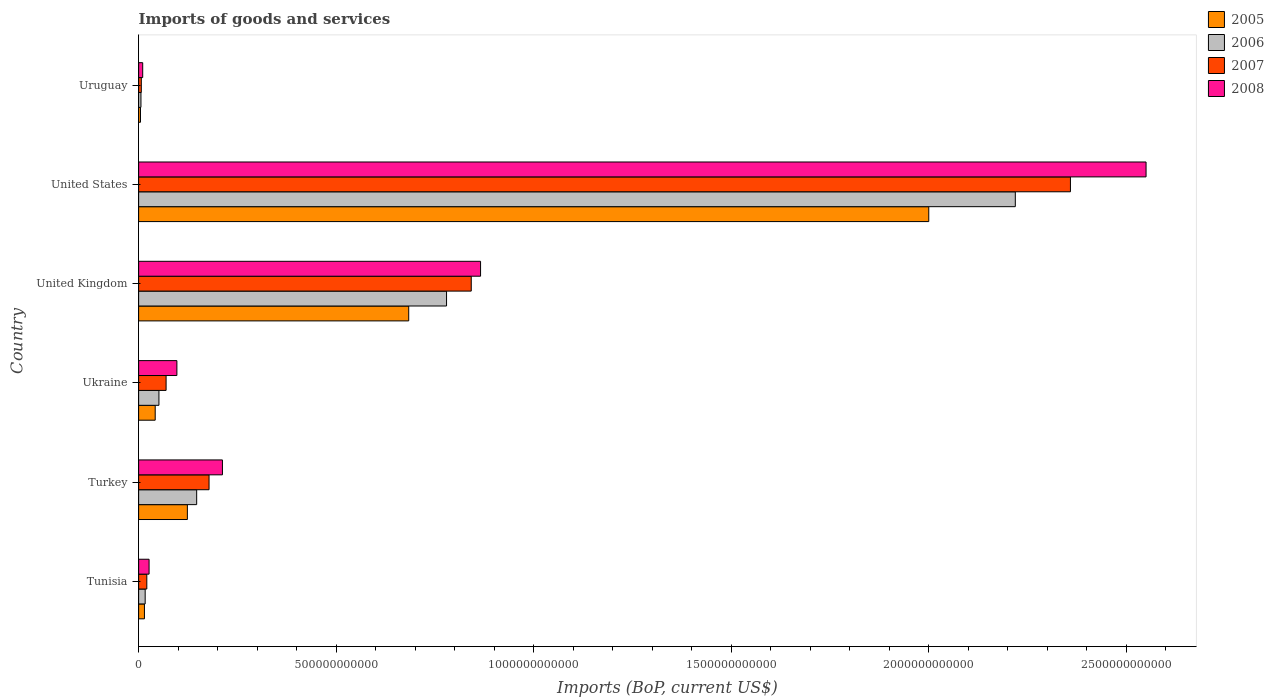Are the number of bars per tick equal to the number of legend labels?
Offer a very short reply. Yes. Are the number of bars on each tick of the Y-axis equal?
Offer a terse response. Yes. How many bars are there on the 5th tick from the top?
Provide a short and direct response. 4. What is the label of the 5th group of bars from the top?
Offer a terse response. Turkey. In how many cases, is the number of bars for a given country not equal to the number of legend labels?
Make the answer very short. 0. What is the amount spent on imports in 2007 in Uruguay?
Your answer should be very brief. 6.78e+09. Across all countries, what is the maximum amount spent on imports in 2006?
Make the answer very short. 2.22e+12. Across all countries, what is the minimum amount spent on imports in 2008?
Your answer should be compact. 1.03e+1. In which country was the amount spent on imports in 2006 maximum?
Make the answer very short. United States. In which country was the amount spent on imports in 2005 minimum?
Your answer should be very brief. Uruguay. What is the total amount spent on imports in 2005 in the graph?
Offer a terse response. 2.87e+12. What is the difference between the amount spent on imports in 2006 in United States and that in Uruguay?
Your answer should be very brief. 2.21e+12. What is the difference between the amount spent on imports in 2007 in Tunisia and the amount spent on imports in 2008 in Turkey?
Ensure brevity in your answer.  -1.91e+11. What is the average amount spent on imports in 2007 per country?
Provide a short and direct response. 5.79e+11. What is the difference between the amount spent on imports in 2006 and amount spent on imports in 2005 in Tunisia?
Keep it short and to the point. 1.86e+09. What is the ratio of the amount spent on imports in 2008 in Tunisia to that in Uruguay?
Provide a short and direct response. 2.56. Is the amount spent on imports in 2006 in Ukraine less than that in United Kingdom?
Give a very brief answer. Yes. What is the difference between the highest and the second highest amount spent on imports in 2006?
Offer a very short reply. 1.44e+12. What is the difference between the highest and the lowest amount spent on imports in 2006?
Your answer should be compact. 2.21e+12. In how many countries, is the amount spent on imports in 2008 greater than the average amount spent on imports in 2008 taken over all countries?
Offer a terse response. 2. Is the sum of the amount spent on imports in 2008 in Tunisia and Uruguay greater than the maximum amount spent on imports in 2006 across all countries?
Offer a very short reply. No. What does the 4th bar from the bottom in United Kingdom represents?
Ensure brevity in your answer.  2008. How many bars are there?
Keep it short and to the point. 24. Are all the bars in the graph horizontal?
Your answer should be compact. Yes. How many countries are there in the graph?
Provide a succinct answer. 6. What is the difference between two consecutive major ticks on the X-axis?
Provide a short and direct response. 5.00e+11. Does the graph contain any zero values?
Your answer should be very brief. No. Does the graph contain grids?
Keep it short and to the point. No. How many legend labels are there?
Offer a very short reply. 4. What is the title of the graph?
Your answer should be compact. Imports of goods and services. Does "1991" appear as one of the legend labels in the graph?
Ensure brevity in your answer.  No. What is the label or title of the X-axis?
Provide a succinct answer. Imports (BoP, current US$). What is the Imports (BoP, current US$) of 2005 in Tunisia?
Make the answer very short. 1.47e+1. What is the Imports (BoP, current US$) of 2006 in Tunisia?
Keep it short and to the point. 1.66e+1. What is the Imports (BoP, current US$) in 2007 in Tunisia?
Ensure brevity in your answer.  2.07e+1. What is the Imports (BoP, current US$) in 2008 in Tunisia?
Your answer should be very brief. 2.64e+1. What is the Imports (BoP, current US$) in 2005 in Turkey?
Offer a terse response. 1.23e+11. What is the Imports (BoP, current US$) in 2006 in Turkey?
Make the answer very short. 1.47e+11. What is the Imports (BoP, current US$) of 2007 in Turkey?
Your response must be concise. 1.78e+11. What is the Imports (BoP, current US$) in 2008 in Turkey?
Make the answer very short. 2.12e+11. What is the Imports (BoP, current US$) in 2005 in Ukraine?
Provide a succinct answer. 4.20e+1. What is the Imports (BoP, current US$) in 2006 in Ukraine?
Your response must be concise. 5.14e+1. What is the Imports (BoP, current US$) of 2007 in Ukraine?
Ensure brevity in your answer.  6.95e+1. What is the Imports (BoP, current US$) in 2008 in Ukraine?
Offer a very short reply. 9.68e+1. What is the Imports (BoP, current US$) in 2005 in United Kingdom?
Offer a terse response. 6.84e+11. What is the Imports (BoP, current US$) of 2006 in United Kingdom?
Provide a succinct answer. 7.80e+11. What is the Imports (BoP, current US$) in 2007 in United Kingdom?
Offer a terse response. 8.42e+11. What is the Imports (BoP, current US$) in 2008 in United Kingdom?
Make the answer very short. 8.66e+11. What is the Imports (BoP, current US$) in 2005 in United States?
Provide a succinct answer. 2.00e+12. What is the Imports (BoP, current US$) in 2006 in United States?
Make the answer very short. 2.22e+12. What is the Imports (BoP, current US$) of 2007 in United States?
Give a very brief answer. 2.36e+12. What is the Imports (BoP, current US$) in 2008 in United States?
Your response must be concise. 2.55e+12. What is the Imports (BoP, current US$) of 2005 in Uruguay?
Give a very brief answer. 4.69e+09. What is the Imports (BoP, current US$) of 2006 in Uruguay?
Your response must be concise. 5.88e+09. What is the Imports (BoP, current US$) in 2007 in Uruguay?
Your response must be concise. 6.78e+09. What is the Imports (BoP, current US$) of 2008 in Uruguay?
Make the answer very short. 1.03e+1. Across all countries, what is the maximum Imports (BoP, current US$) of 2005?
Ensure brevity in your answer.  2.00e+12. Across all countries, what is the maximum Imports (BoP, current US$) in 2006?
Your answer should be compact. 2.22e+12. Across all countries, what is the maximum Imports (BoP, current US$) in 2007?
Make the answer very short. 2.36e+12. Across all countries, what is the maximum Imports (BoP, current US$) in 2008?
Keep it short and to the point. 2.55e+12. Across all countries, what is the minimum Imports (BoP, current US$) of 2005?
Offer a terse response. 4.69e+09. Across all countries, what is the minimum Imports (BoP, current US$) in 2006?
Ensure brevity in your answer.  5.88e+09. Across all countries, what is the minimum Imports (BoP, current US$) in 2007?
Your response must be concise. 6.78e+09. Across all countries, what is the minimum Imports (BoP, current US$) of 2008?
Ensure brevity in your answer.  1.03e+1. What is the total Imports (BoP, current US$) in 2005 in the graph?
Keep it short and to the point. 2.87e+12. What is the total Imports (BoP, current US$) of 2006 in the graph?
Provide a succinct answer. 3.22e+12. What is the total Imports (BoP, current US$) in 2007 in the graph?
Your answer should be compact. 3.48e+12. What is the total Imports (BoP, current US$) of 2008 in the graph?
Give a very brief answer. 3.76e+12. What is the difference between the Imports (BoP, current US$) of 2005 in Tunisia and that in Turkey?
Ensure brevity in your answer.  -1.09e+11. What is the difference between the Imports (BoP, current US$) of 2006 in Tunisia and that in Turkey?
Your answer should be very brief. -1.30e+11. What is the difference between the Imports (BoP, current US$) of 2007 in Tunisia and that in Turkey?
Your answer should be very brief. -1.58e+11. What is the difference between the Imports (BoP, current US$) of 2008 in Tunisia and that in Turkey?
Make the answer very short. -1.86e+11. What is the difference between the Imports (BoP, current US$) in 2005 in Tunisia and that in Ukraine?
Provide a succinct answer. -2.73e+1. What is the difference between the Imports (BoP, current US$) in 2006 in Tunisia and that in Ukraine?
Your answer should be very brief. -3.49e+1. What is the difference between the Imports (BoP, current US$) of 2007 in Tunisia and that in Ukraine?
Keep it short and to the point. -4.88e+1. What is the difference between the Imports (BoP, current US$) of 2008 in Tunisia and that in Ukraine?
Your answer should be very brief. -7.04e+1. What is the difference between the Imports (BoP, current US$) in 2005 in Tunisia and that in United Kingdom?
Give a very brief answer. -6.69e+11. What is the difference between the Imports (BoP, current US$) in 2006 in Tunisia and that in United Kingdom?
Your answer should be very brief. -7.63e+11. What is the difference between the Imports (BoP, current US$) in 2007 in Tunisia and that in United Kingdom?
Offer a very short reply. -8.21e+11. What is the difference between the Imports (BoP, current US$) of 2008 in Tunisia and that in United Kingdom?
Your response must be concise. -8.39e+11. What is the difference between the Imports (BoP, current US$) of 2005 in Tunisia and that in United States?
Keep it short and to the point. -1.99e+12. What is the difference between the Imports (BoP, current US$) in 2006 in Tunisia and that in United States?
Make the answer very short. -2.20e+12. What is the difference between the Imports (BoP, current US$) of 2007 in Tunisia and that in United States?
Keep it short and to the point. -2.34e+12. What is the difference between the Imports (BoP, current US$) of 2008 in Tunisia and that in United States?
Give a very brief answer. -2.52e+12. What is the difference between the Imports (BoP, current US$) in 2005 in Tunisia and that in Uruguay?
Your answer should be very brief. 1.00e+1. What is the difference between the Imports (BoP, current US$) of 2006 in Tunisia and that in Uruguay?
Keep it short and to the point. 1.07e+1. What is the difference between the Imports (BoP, current US$) of 2007 in Tunisia and that in Uruguay?
Give a very brief answer. 1.40e+1. What is the difference between the Imports (BoP, current US$) in 2008 in Tunisia and that in Uruguay?
Keep it short and to the point. 1.61e+1. What is the difference between the Imports (BoP, current US$) of 2005 in Turkey and that in Ukraine?
Make the answer very short. 8.14e+1. What is the difference between the Imports (BoP, current US$) in 2006 in Turkey and that in Ukraine?
Provide a short and direct response. 9.55e+1. What is the difference between the Imports (BoP, current US$) of 2007 in Turkey and that in Ukraine?
Your answer should be compact. 1.09e+11. What is the difference between the Imports (BoP, current US$) of 2008 in Turkey and that in Ukraine?
Your response must be concise. 1.15e+11. What is the difference between the Imports (BoP, current US$) in 2005 in Turkey and that in United Kingdom?
Provide a succinct answer. -5.60e+11. What is the difference between the Imports (BoP, current US$) in 2006 in Turkey and that in United Kingdom?
Provide a short and direct response. -6.33e+11. What is the difference between the Imports (BoP, current US$) of 2007 in Turkey and that in United Kingdom?
Ensure brevity in your answer.  -6.64e+11. What is the difference between the Imports (BoP, current US$) in 2008 in Turkey and that in United Kingdom?
Provide a succinct answer. -6.53e+11. What is the difference between the Imports (BoP, current US$) in 2005 in Turkey and that in United States?
Your response must be concise. -1.88e+12. What is the difference between the Imports (BoP, current US$) of 2006 in Turkey and that in United States?
Provide a short and direct response. -2.07e+12. What is the difference between the Imports (BoP, current US$) of 2007 in Turkey and that in United States?
Offer a terse response. -2.18e+12. What is the difference between the Imports (BoP, current US$) in 2008 in Turkey and that in United States?
Make the answer very short. -2.34e+12. What is the difference between the Imports (BoP, current US$) in 2005 in Turkey and that in Uruguay?
Keep it short and to the point. 1.19e+11. What is the difference between the Imports (BoP, current US$) in 2006 in Turkey and that in Uruguay?
Provide a succinct answer. 1.41e+11. What is the difference between the Imports (BoP, current US$) of 2007 in Turkey and that in Uruguay?
Your answer should be compact. 1.72e+11. What is the difference between the Imports (BoP, current US$) in 2008 in Turkey and that in Uruguay?
Keep it short and to the point. 2.02e+11. What is the difference between the Imports (BoP, current US$) in 2005 in Ukraine and that in United Kingdom?
Make the answer very short. -6.42e+11. What is the difference between the Imports (BoP, current US$) in 2006 in Ukraine and that in United Kingdom?
Offer a terse response. -7.28e+11. What is the difference between the Imports (BoP, current US$) of 2007 in Ukraine and that in United Kingdom?
Ensure brevity in your answer.  -7.72e+11. What is the difference between the Imports (BoP, current US$) in 2008 in Ukraine and that in United Kingdom?
Offer a terse response. -7.69e+11. What is the difference between the Imports (BoP, current US$) of 2005 in Ukraine and that in United States?
Your answer should be compact. -1.96e+12. What is the difference between the Imports (BoP, current US$) in 2006 in Ukraine and that in United States?
Your answer should be very brief. -2.17e+12. What is the difference between the Imports (BoP, current US$) in 2007 in Ukraine and that in United States?
Make the answer very short. -2.29e+12. What is the difference between the Imports (BoP, current US$) in 2008 in Ukraine and that in United States?
Ensure brevity in your answer.  -2.45e+12. What is the difference between the Imports (BoP, current US$) of 2005 in Ukraine and that in Uruguay?
Your response must be concise. 3.73e+1. What is the difference between the Imports (BoP, current US$) of 2006 in Ukraine and that in Uruguay?
Ensure brevity in your answer.  4.55e+1. What is the difference between the Imports (BoP, current US$) of 2007 in Ukraine and that in Uruguay?
Your answer should be very brief. 6.28e+1. What is the difference between the Imports (BoP, current US$) of 2008 in Ukraine and that in Uruguay?
Ensure brevity in your answer.  8.65e+1. What is the difference between the Imports (BoP, current US$) in 2005 in United Kingdom and that in United States?
Keep it short and to the point. -1.32e+12. What is the difference between the Imports (BoP, current US$) of 2006 in United Kingdom and that in United States?
Ensure brevity in your answer.  -1.44e+12. What is the difference between the Imports (BoP, current US$) in 2007 in United Kingdom and that in United States?
Your answer should be compact. -1.52e+12. What is the difference between the Imports (BoP, current US$) in 2008 in United Kingdom and that in United States?
Give a very brief answer. -1.68e+12. What is the difference between the Imports (BoP, current US$) of 2005 in United Kingdom and that in Uruguay?
Your answer should be very brief. 6.79e+11. What is the difference between the Imports (BoP, current US$) of 2006 in United Kingdom and that in Uruguay?
Make the answer very short. 7.74e+11. What is the difference between the Imports (BoP, current US$) in 2007 in United Kingdom and that in Uruguay?
Ensure brevity in your answer.  8.35e+11. What is the difference between the Imports (BoP, current US$) of 2008 in United Kingdom and that in Uruguay?
Make the answer very short. 8.55e+11. What is the difference between the Imports (BoP, current US$) in 2005 in United States and that in Uruguay?
Offer a very short reply. 2.00e+12. What is the difference between the Imports (BoP, current US$) in 2006 in United States and that in Uruguay?
Provide a short and direct response. 2.21e+12. What is the difference between the Imports (BoP, current US$) in 2007 in United States and that in Uruguay?
Provide a short and direct response. 2.35e+12. What is the difference between the Imports (BoP, current US$) of 2008 in United States and that in Uruguay?
Your answer should be very brief. 2.54e+12. What is the difference between the Imports (BoP, current US$) in 2005 in Tunisia and the Imports (BoP, current US$) in 2006 in Turkey?
Make the answer very short. -1.32e+11. What is the difference between the Imports (BoP, current US$) in 2005 in Tunisia and the Imports (BoP, current US$) in 2007 in Turkey?
Keep it short and to the point. -1.64e+11. What is the difference between the Imports (BoP, current US$) of 2005 in Tunisia and the Imports (BoP, current US$) of 2008 in Turkey?
Make the answer very short. -1.97e+11. What is the difference between the Imports (BoP, current US$) of 2006 in Tunisia and the Imports (BoP, current US$) of 2007 in Turkey?
Give a very brief answer. -1.62e+11. What is the difference between the Imports (BoP, current US$) in 2006 in Tunisia and the Imports (BoP, current US$) in 2008 in Turkey?
Provide a succinct answer. -1.96e+11. What is the difference between the Imports (BoP, current US$) of 2007 in Tunisia and the Imports (BoP, current US$) of 2008 in Turkey?
Give a very brief answer. -1.91e+11. What is the difference between the Imports (BoP, current US$) of 2005 in Tunisia and the Imports (BoP, current US$) of 2006 in Ukraine?
Your response must be concise. -3.67e+1. What is the difference between the Imports (BoP, current US$) in 2005 in Tunisia and the Imports (BoP, current US$) in 2007 in Ukraine?
Give a very brief answer. -5.48e+1. What is the difference between the Imports (BoP, current US$) in 2005 in Tunisia and the Imports (BoP, current US$) in 2008 in Ukraine?
Keep it short and to the point. -8.21e+1. What is the difference between the Imports (BoP, current US$) of 2006 in Tunisia and the Imports (BoP, current US$) of 2007 in Ukraine?
Make the answer very short. -5.30e+1. What is the difference between the Imports (BoP, current US$) of 2006 in Tunisia and the Imports (BoP, current US$) of 2008 in Ukraine?
Your answer should be very brief. -8.03e+1. What is the difference between the Imports (BoP, current US$) in 2007 in Tunisia and the Imports (BoP, current US$) in 2008 in Ukraine?
Ensure brevity in your answer.  -7.61e+1. What is the difference between the Imports (BoP, current US$) of 2005 in Tunisia and the Imports (BoP, current US$) of 2006 in United Kingdom?
Give a very brief answer. -7.65e+11. What is the difference between the Imports (BoP, current US$) of 2005 in Tunisia and the Imports (BoP, current US$) of 2007 in United Kingdom?
Your answer should be compact. -8.27e+11. What is the difference between the Imports (BoP, current US$) in 2005 in Tunisia and the Imports (BoP, current US$) in 2008 in United Kingdom?
Make the answer very short. -8.51e+11. What is the difference between the Imports (BoP, current US$) in 2006 in Tunisia and the Imports (BoP, current US$) in 2007 in United Kingdom?
Give a very brief answer. -8.25e+11. What is the difference between the Imports (BoP, current US$) in 2006 in Tunisia and the Imports (BoP, current US$) in 2008 in United Kingdom?
Offer a very short reply. -8.49e+11. What is the difference between the Imports (BoP, current US$) of 2007 in Tunisia and the Imports (BoP, current US$) of 2008 in United Kingdom?
Provide a short and direct response. -8.45e+11. What is the difference between the Imports (BoP, current US$) in 2005 in Tunisia and the Imports (BoP, current US$) in 2006 in United States?
Offer a terse response. -2.20e+12. What is the difference between the Imports (BoP, current US$) in 2005 in Tunisia and the Imports (BoP, current US$) in 2007 in United States?
Your answer should be compact. -2.34e+12. What is the difference between the Imports (BoP, current US$) in 2005 in Tunisia and the Imports (BoP, current US$) in 2008 in United States?
Provide a succinct answer. -2.54e+12. What is the difference between the Imports (BoP, current US$) of 2006 in Tunisia and the Imports (BoP, current US$) of 2007 in United States?
Offer a terse response. -2.34e+12. What is the difference between the Imports (BoP, current US$) of 2006 in Tunisia and the Imports (BoP, current US$) of 2008 in United States?
Offer a terse response. -2.53e+12. What is the difference between the Imports (BoP, current US$) of 2007 in Tunisia and the Imports (BoP, current US$) of 2008 in United States?
Your response must be concise. -2.53e+12. What is the difference between the Imports (BoP, current US$) in 2005 in Tunisia and the Imports (BoP, current US$) in 2006 in Uruguay?
Provide a short and direct response. 8.82e+09. What is the difference between the Imports (BoP, current US$) of 2005 in Tunisia and the Imports (BoP, current US$) of 2007 in Uruguay?
Ensure brevity in your answer.  7.93e+09. What is the difference between the Imports (BoP, current US$) of 2005 in Tunisia and the Imports (BoP, current US$) of 2008 in Uruguay?
Keep it short and to the point. 4.37e+09. What is the difference between the Imports (BoP, current US$) of 2006 in Tunisia and the Imports (BoP, current US$) of 2007 in Uruguay?
Your response must be concise. 9.79e+09. What is the difference between the Imports (BoP, current US$) in 2006 in Tunisia and the Imports (BoP, current US$) in 2008 in Uruguay?
Offer a very short reply. 6.23e+09. What is the difference between the Imports (BoP, current US$) of 2007 in Tunisia and the Imports (BoP, current US$) of 2008 in Uruguay?
Keep it short and to the point. 1.04e+1. What is the difference between the Imports (BoP, current US$) of 2005 in Turkey and the Imports (BoP, current US$) of 2006 in Ukraine?
Give a very brief answer. 7.20e+1. What is the difference between the Imports (BoP, current US$) of 2005 in Turkey and the Imports (BoP, current US$) of 2007 in Ukraine?
Give a very brief answer. 5.39e+1. What is the difference between the Imports (BoP, current US$) of 2005 in Turkey and the Imports (BoP, current US$) of 2008 in Ukraine?
Your answer should be compact. 2.65e+1. What is the difference between the Imports (BoP, current US$) of 2006 in Turkey and the Imports (BoP, current US$) of 2007 in Ukraine?
Your answer should be very brief. 7.74e+1. What is the difference between the Imports (BoP, current US$) of 2006 in Turkey and the Imports (BoP, current US$) of 2008 in Ukraine?
Give a very brief answer. 5.01e+1. What is the difference between the Imports (BoP, current US$) of 2007 in Turkey and the Imports (BoP, current US$) of 2008 in Ukraine?
Provide a short and direct response. 8.14e+1. What is the difference between the Imports (BoP, current US$) in 2005 in Turkey and the Imports (BoP, current US$) in 2006 in United Kingdom?
Your response must be concise. -6.56e+11. What is the difference between the Imports (BoP, current US$) of 2005 in Turkey and the Imports (BoP, current US$) of 2007 in United Kingdom?
Your answer should be very brief. -7.19e+11. What is the difference between the Imports (BoP, current US$) of 2005 in Turkey and the Imports (BoP, current US$) of 2008 in United Kingdom?
Your response must be concise. -7.42e+11. What is the difference between the Imports (BoP, current US$) of 2006 in Turkey and the Imports (BoP, current US$) of 2007 in United Kingdom?
Your answer should be compact. -6.95e+11. What is the difference between the Imports (BoP, current US$) in 2006 in Turkey and the Imports (BoP, current US$) in 2008 in United Kingdom?
Offer a terse response. -7.19e+11. What is the difference between the Imports (BoP, current US$) of 2007 in Turkey and the Imports (BoP, current US$) of 2008 in United Kingdom?
Ensure brevity in your answer.  -6.87e+11. What is the difference between the Imports (BoP, current US$) of 2005 in Turkey and the Imports (BoP, current US$) of 2006 in United States?
Give a very brief answer. -2.10e+12. What is the difference between the Imports (BoP, current US$) of 2005 in Turkey and the Imports (BoP, current US$) of 2007 in United States?
Give a very brief answer. -2.24e+12. What is the difference between the Imports (BoP, current US$) in 2005 in Turkey and the Imports (BoP, current US$) in 2008 in United States?
Offer a terse response. -2.43e+12. What is the difference between the Imports (BoP, current US$) in 2006 in Turkey and the Imports (BoP, current US$) in 2007 in United States?
Offer a terse response. -2.21e+12. What is the difference between the Imports (BoP, current US$) of 2006 in Turkey and the Imports (BoP, current US$) of 2008 in United States?
Provide a short and direct response. -2.40e+12. What is the difference between the Imports (BoP, current US$) in 2007 in Turkey and the Imports (BoP, current US$) in 2008 in United States?
Give a very brief answer. -2.37e+12. What is the difference between the Imports (BoP, current US$) in 2005 in Turkey and the Imports (BoP, current US$) in 2006 in Uruguay?
Provide a succinct answer. 1.18e+11. What is the difference between the Imports (BoP, current US$) of 2005 in Turkey and the Imports (BoP, current US$) of 2007 in Uruguay?
Make the answer very short. 1.17e+11. What is the difference between the Imports (BoP, current US$) in 2005 in Turkey and the Imports (BoP, current US$) in 2008 in Uruguay?
Give a very brief answer. 1.13e+11. What is the difference between the Imports (BoP, current US$) in 2006 in Turkey and the Imports (BoP, current US$) in 2007 in Uruguay?
Your answer should be very brief. 1.40e+11. What is the difference between the Imports (BoP, current US$) of 2006 in Turkey and the Imports (BoP, current US$) of 2008 in Uruguay?
Make the answer very short. 1.37e+11. What is the difference between the Imports (BoP, current US$) in 2007 in Turkey and the Imports (BoP, current US$) in 2008 in Uruguay?
Offer a very short reply. 1.68e+11. What is the difference between the Imports (BoP, current US$) in 2005 in Ukraine and the Imports (BoP, current US$) in 2006 in United Kingdom?
Offer a very short reply. -7.38e+11. What is the difference between the Imports (BoP, current US$) in 2005 in Ukraine and the Imports (BoP, current US$) in 2007 in United Kingdom?
Ensure brevity in your answer.  -8.00e+11. What is the difference between the Imports (BoP, current US$) of 2005 in Ukraine and the Imports (BoP, current US$) of 2008 in United Kingdom?
Your answer should be compact. -8.24e+11. What is the difference between the Imports (BoP, current US$) in 2006 in Ukraine and the Imports (BoP, current US$) in 2007 in United Kingdom?
Your answer should be very brief. -7.91e+11. What is the difference between the Imports (BoP, current US$) in 2006 in Ukraine and the Imports (BoP, current US$) in 2008 in United Kingdom?
Ensure brevity in your answer.  -8.14e+11. What is the difference between the Imports (BoP, current US$) in 2007 in Ukraine and the Imports (BoP, current US$) in 2008 in United Kingdom?
Ensure brevity in your answer.  -7.96e+11. What is the difference between the Imports (BoP, current US$) in 2005 in Ukraine and the Imports (BoP, current US$) in 2006 in United States?
Offer a terse response. -2.18e+12. What is the difference between the Imports (BoP, current US$) in 2005 in Ukraine and the Imports (BoP, current US$) in 2007 in United States?
Offer a terse response. -2.32e+12. What is the difference between the Imports (BoP, current US$) in 2005 in Ukraine and the Imports (BoP, current US$) in 2008 in United States?
Provide a succinct answer. -2.51e+12. What is the difference between the Imports (BoP, current US$) of 2006 in Ukraine and the Imports (BoP, current US$) of 2007 in United States?
Make the answer very short. -2.31e+12. What is the difference between the Imports (BoP, current US$) in 2006 in Ukraine and the Imports (BoP, current US$) in 2008 in United States?
Your answer should be very brief. -2.50e+12. What is the difference between the Imports (BoP, current US$) of 2007 in Ukraine and the Imports (BoP, current US$) of 2008 in United States?
Your answer should be very brief. -2.48e+12. What is the difference between the Imports (BoP, current US$) of 2005 in Ukraine and the Imports (BoP, current US$) of 2006 in Uruguay?
Make the answer very short. 3.61e+1. What is the difference between the Imports (BoP, current US$) of 2005 in Ukraine and the Imports (BoP, current US$) of 2007 in Uruguay?
Your answer should be compact. 3.52e+1. What is the difference between the Imports (BoP, current US$) of 2005 in Ukraine and the Imports (BoP, current US$) of 2008 in Uruguay?
Ensure brevity in your answer.  3.16e+1. What is the difference between the Imports (BoP, current US$) of 2006 in Ukraine and the Imports (BoP, current US$) of 2007 in Uruguay?
Make the answer very short. 4.46e+1. What is the difference between the Imports (BoP, current US$) in 2006 in Ukraine and the Imports (BoP, current US$) in 2008 in Uruguay?
Ensure brevity in your answer.  4.11e+1. What is the difference between the Imports (BoP, current US$) in 2007 in Ukraine and the Imports (BoP, current US$) in 2008 in Uruguay?
Keep it short and to the point. 5.92e+1. What is the difference between the Imports (BoP, current US$) in 2005 in United Kingdom and the Imports (BoP, current US$) in 2006 in United States?
Your answer should be very brief. -1.54e+12. What is the difference between the Imports (BoP, current US$) of 2005 in United Kingdom and the Imports (BoP, current US$) of 2007 in United States?
Ensure brevity in your answer.  -1.68e+12. What is the difference between the Imports (BoP, current US$) in 2005 in United Kingdom and the Imports (BoP, current US$) in 2008 in United States?
Make the answer very short. -1.87e+12. What is the difference between the Imports (BoP, current US$) of 2006 in United Kingdom and the Imports (BoP, current US$) of 2007 in United States?
Offer a very short reply. -1.58e+12. What is the difference between the Imports (BoP, current US$) of 2006 in United Kingdom and the Imports (BoP, current US$) of 2008 in United States?
Your response must be concise. -1.77e+12. What is the difference between the Imports (BoP, current US$) of 2007 in United Kingdom and the Imports (BoP, current US$) of 2008 in United States?
Your response must be concise. -1.71e+12. What is the difference between the Imports (BoP, current US$) in 2005 in United Kingdom and the Imports (BoP, current US$) in 2006 in Uruguay?
Offer a very short reply. 6.78e+11. What is the difference between the Imports (BoP, current US$) in 2005 in United Kingdom and the Imports (BoP, current US$) in 2007 in Uruguay?
Provide a succinct answer. 6.77e+11. What is the difference between the Imports (BoP, current US$) of 2005 in United Kingdom and the Imports (BoP, current US$) of 2008 in Uruguay?
Offer a very short reply. 6.73e+11. What is the difference between the Imports (BoP, current US$) of 2006 in United Kingdom and the Imports (BoP, current US$) of 2007 in Uruguay?
Your answer should be compact. 7.73e+11. What is the difference between the Imports (BoP, current US$) of 2006 in United Kingdom and the Imports (BoP, current US$) of 2008 in Uruguay?
Your response must be concise. 7.69e+11. What is the difference between the Imports (BoP, current US$) in 2007 in United Kingdom and the Imports (BoP, current US$) in 2008 in Uruguay?
Ensure brevity in your answer.  8.32e+11. What is the difference between the Imports (BoP, current US$) of 2005 in United States and the Imports (BoP, current US$) of 2006 in Uruguay?
Offer a terse response. 1.99e+12. What is the difference between the Imports (BoP, current US$) of 2005 in United States and the Imports (BoP, current US$) of 2007 in Uruguay?
Give a very brief answer. 1.99e+12. What is the difference between the Imports (BoP, current US$) in 2005 in United States and the Imports (BoP, current US$) in 2008 in Uruguay?
Provide a short and direct response. 1.99e+12. What is the difference between the Imports (BoP, current US$) in 2006 in United States and the Imports (BoP, current US$) in 2007 in Uruguay?
Provide a succinct answer. 2.21e+12. What is the difference between the Imports (BoP, current US$) in 2006 in United States and the Imports (BoP, current US$) in 2008 in Uruguay?
Offer a very short reply. 2.21e+12. What is the difference between the Imports (BoP, current US$) in 2007 in United States and the Imports (BoP, current US$) in 2008 in Uruguay?
Give a very brief answer. 2.35e+12. What is the average Imports (BoP, current US$) of 2005 per country?
Your answer should be very brief. 4.78e+11. What is the average Imports (BoP, current US$) of 2006 per country?
Give a very brief answer. 5.37e+11. What is the average Imports (BoP, current US$) of 2007 per country?
Your answer should be very brief. 5.79e+11. What is the average Imports (BoP, current US$) of 2008 per country?
Your answer should be compact. 6.27e+11. What is the difference between the Imports (BoP, current US$) of 2005 and Imports (BoP, current US$) of 2006 in Tunisia?
Make the answer very short. -1.86e+09. What is the difference between the Imports (BoP, current US$) in 2005 and Imports (BoP, current US$) in 2007 in Tunisia?
Ensure brevity in your answer.  -6.03e+09. What is the difference between the Imports (BoP, current US$) in 2005 and Imports (BoP, current US$) in 2008 in Tunisia?
Offer a terse response. -1.17e+1. What is the difference between the Imports (BoP, current US$) in 2006 and Imports (BoP, current US$) in 2007 in Tunisia?
Give a very brief answer. -4.17e+09. What is the difference between the Imports (BoP, current US$) in 2006 and Imports (BoP, current US$) in 2008 in Tunisia?
Your answer should be compact. -9.88e+09. What is the difference between the Imports (BoP, current US$) of 2007 and Imports (BoP, current US$) of 2008 in Tunisia?
Offer a very short reply. -5.71e+09. What is the difference between the Imports (BoP, current US$) in 2005 and Imports (BoP, current US$) in 2006 in Turkey?
Your answer should be very brief. -2.35e+1. What is the difference between the Imports (BoP, current US$) in 2005 and Imports (BoP, current US$) in 2007 in Turkey?
Your answer should be very brief. -5.49e+1. What is the difference between the Imports (BoP, current US$) in 2005 and Imports (BoP, current US$) in 2008 in Turkey?
Your answer should be very brief. -8.88e+1. What is the difference between the Imports (BoP, current US$) of 2006 and Imports (BoP, current US$) of 2007 in Turkey?
Your answer should be very brief. -3.13e+1. What is the difference between the Imports (BoP, current US$) of 2006 and Imports (BoP, current US$) of 2008 in Turkey?
Your answer should be very brief. -6.52e+1. What is the difference between the Imports (BoP, current US$) of 2007 and Imports (BoP, current US$) of 2008 in Turkey?
Your answer should be compact. -3.39e+1. What is the difference between the Imports (BoP, current US$) in 2005 and Imports (BoP, current US$) in 2006 in Ukraine?
Your answer should be compact. -9.47e+09. What is the difference between the Imports (BoP, current US$) of 2005 and Imports (BoP, current US$) of 2007 in Ukraine?
Offer a very short reply. -2.76e+1. What is the difference between the Imports (BoP, current US$) of 2005 and Imports (BoP, current US$) of 2008 in Ukraine?
Offer a very short reply. -5.49e+1. What is the difference between the Imports (BoP, current US$) of 2006 and Imports (BoP, current US$) of 2007 in Ukraine?
Give a very brief answer. -1.81e+1. What is the difference between the Imports (BoP, current US$) of 2006 and Imports (BoP, current US$) of 2008 in Ukraine?
Offer a terse response. -4.54e+1. What is the difference between the Imports (BoP, current US$) in 2007 and Imports (BoP, current US$) in 2008 in Ukraine?
Your answer should be very brief. -2.73e+1. What is the difference between the Imports (BoP, current US$) of 2005 and Imports (BoP, current US$) of 2006 in United Kingdom?
Make the answer very short. -9.58e+1. What is the difference between the Imports (BoP, current US$) in 2005 and Imports (BoP, current US$) in 2007 in United Kingdom?
Ensure brevity in your answer.  -1.58e+11. What is the difference between the Imports (BoP, current US$) of 2005 and Imports (BoP, current US$) of 2008 in United Kingdom?
Offer a very short reply. -1.82e+11. What is the difference between the Imports (BoP, current US$) of 2006 and Imports (BoP, current US$) of 2007 in United Kingdom?
Your answer should be compact. -6.25e+1. What is the difference between the Imports (BoP, current US$) of 2006 and Imports (BoP, current US$) of 2008 in United Kingdom?
Keep it short and to the point. -8.61e+1. What is the difference between the Imports (BoP, current US$) of 2007 and Imports (BoP, current US$) of 2008 in United Kingdom?
Provide a short and direct response. -2.36e+1. What is the difference between the Imports (BoP, current US$) of 2005 and Imports (BoP, current US$) of 2006 in United States?
Ensure brevity in your answer.  -2.19e+11. What is the difference between the Imports (BoP, current US$) in 2005 and Imports (BoP, current US$) in 2007 in United States?
Make the answer very short. -3.59e+11. What is the difference between the Imports (BoP, current US$) of 2005 and Imports (BoP, current US$) of 2008 in United States?
Keep it short and to the point. -5.50e+11. What is the difference between the Imports (BoP, current US$) of 2006 and Imports (BoP, current US$) of 2007 in United States?
Your answer should be compact. -1.40e+11. What is the difference between the Imports (BoP, current US$) in 2006 and Imports (BoP, current US$) in 2008 in United States?
Give a very brief answer. -3.31e+11. What is the difference between the Imports (BoP, current US$) in 2007 and Imports (BoP, current US$) in 2008 in United States?
Your response must be concise. -1.91e+11. What is the difference between the Imports (BoP, current US$) in 2005 and Imports (BoP, current US$) in 2006 in Uruguay?
Offer a very short reply. -1.18e+09. What is the difference between the Imports (BoP, current US$) in 2005 and Imports (BoP, current US$) in 2007 in Uruguay?
Ensure brevity in your answer.  -2.08e+09. What is the difference between the Imports (BoP, current US$) in 2005 and Imports (BoP, current US$) in 2008 in Uruguay?
Offer a very short reply. -5.64e+09. What is the difference between the Imports (BoP, current US$) in 2006 and Imports (BoP, current US$) in 2007 in Uruguay?
Give a very brief answer. -8.98e+08. What is the difference between the Imports (BoP, current US$) of 2006 and Imports (BoP, current US$) of 2008 in Uruguay?
Offer a very short reply. -4.46e+09. What is the difference between the Imports (BoP, current US$) of 2007 and Imports (BoP, current US$) of 2008 in Uruguay?
Offer a terse response. -3.56e+09. What is the ratio of the Imports (BoP, current US$) in 2005 in Tunisia to that in Turkey?
Make the answer very short. 0.12. What is the ratio of the Imports (BoP, current US$) of 2006 in Tunisia to that in Turkey?
Provide a succinct answer. 0.11. What is the ratio of the Imports (BoP, current US$) in 2007 in Tunisia to that in Turkey?
Your answer should be very brief. 0.12. What is the ratio of the Imports (BoP, current US$) in 2008 in Tunisia to that in Turkey?
Ensure brevity in your answer.  0.12. What is the ratio of the Imports (BoP, current US$) in 2005 in Tunisia to that in Ukraine?
Your answer should be compact. 0.35. What is the ratio of the Imports (BoP, current US$) in 2006 in Tunisia to that in Ukraine?
Make the answer very short. 0.32. What is the ratio of the Imports (BoP, current US$) of 2007 in Tunisia to that in Ukraine?
Provide a short and direct response. 0.3. What is the ratio of the Imports (BoP, current US$) in 2008 in Tunisia to that in Ukraine?
Your answer should be very brief. 0.27. What is the ratio of the Imports (BoP, current US$) of 2005 in Tunisia to that in United Kingdom?
Your response must be concise. 0.02. What is the ratio of the Imports (BoP, current US$) in 2006 in Tunisia to that in United Kingdom?
Offer a very short reply. 0.02. What is the ratio of the Imports (BoP, current US$) of 2007 in Tunisia to that in United Kingdom?
Make the answer very short. 0.02. What is the ratio of the Imports (BoP, current US$) in 2008 in Tunisia to that in United Kingdom?
Provide a short and direct response. 0.03. What is the ratio of the Imports (BoP, current US$) in 2005 in Tunisia to that in United States?
Your answer should be compact. 0.01. What is the ratio of the Imports (BoP, current US$) of 2006 in Tunisia to that in United States?
Offer a very short reply. 0.01. What is the ratio of the Imports (BoP, current US$) of 2007 in Tunisia to that in United States?
Make the answer very short. 0.01. What is the ratio of the Imports (BoP, current US$) of 2008 in Tunisia to that in United States?
Make the answer very short. 0.01. What is the ratio of the Imports (BoP, current US$) in 2005 in Tunisia to that in Uruguay?
Your response must be concise. 3.13. What is the ratio of the Imports (BoP, current US$) in 2006 in Tunisia to that in Uruguay?
Offer a terse response. 2.82. What is the ratio of the Imports (BoP, current US$) in 2007 in Tunisia to that in Uruguay?
Make the answer very short. 3.06. What is the ratio of the Imports (BoP, current US$) in 2008 in Tunisia to that in Uruguay?
Provide a short and direct response. 2.56. What is the ratio of the Imports (BoP, current US$) of 2005 in Turkey to that in Ukraine?
Give a very brief answer. 2.94. What is the ratio of the Imports (BoP, current US$) of 2006 in Turkey to that in Ukraine?
Ensure brevity in your answer.  2.86. What is the ratio of the Imports (BoP, current US$) of 2007 in Turkey to that in Ukraine?
Give a very brief answer. 2.56. What is the ratio of the Imports (BoP, current US$) in 2008 in Turkey to that in Ukraine?
Your answer should be compact. 2.19. What is the ratio of the Imports (BoP, current US$) of 2005 in Turkey to that in United Kingdom?
Keep it short and to the point. 0.18. What is the ratio of the Imports (BoP, current US$) in 2006 in Turkey to that in United Kingdom?
Your answer should be very brief. 0.19. What is the ratio of the Imports (BoP, current US$) in 2007 in Turkey to that in United Kingdom?
Give a very brief answer. 0.21. What is the ratio of the Imports (BoP, current US$) of 2008 in Turkey to that in United Kingdom?
Provide a short and direct response. 0.25. What is the ratio of the Imports (BoP, current US$) of 2005 in Turkey to that in United States?
Make the answer very short. 0.06. What is the ratio of the Imports (BoP, current US$) of 2006 in Turkey to that in United States?
Your answer should be compact. 0.07. What is the ratio of the Imports (BoP, current US$) in 2007 in Turkey to that in United States?
Keep it short and to the point. 0.08. What is the ratio of the Imports (BoP, current US$) of 2008 in Turkey to that in United States?
Your answer should be compact. 0.08. What is the ratio of the Imports (BoP, current US$) in 2005 in Turkey to that in Uruguay?
Give a very brief answer. 26.29. What is the ratio of the Imports (BoP, current US$) in 2006 in Turkey to that in Uruguay?
Your answer should be compact. 25. What is the ratio of the Imports (BoP, current US$) in 2007 in Turkey to that in Uruguay?
Provide a succinct answer. 26.31. What is the ratio of the Imports (BoP, current US$) in 2008 in Turkey to that in Uruguay?
Keep it short and to the point. 20.53. What is the ratio of the Imports (BoP, current US$) in 2005 in Ukraine to that in United Kingdom?
Ensure brevity in your answer.  0.06. What is the ratio of the Imports (BoP, current US$) of 2006 in Ukraine to that in United Kingdom?
Make the answer very short. 0.07. What is the ratio of the Imports (BoP, current US$) of 2007 in Ukraine to that in United Kingdom?
Your response must be concise. 0.08. What is the ratio of the Imports (BoP, current US$) in 2008 in Ukraine to that in United Kingdom?
Provide a short and direct response. 0.11. What is the ratio of the Imports (BoP, current US$) in 2005 in Ukraine to that in United States?
Offer a very short reply. 0.02. What is the ratio of the Imports (BoP, current US$) of 2006 in Ukraine to that in United States?
Ensure brevity in your answer.  0.02. What is the ratio of the Imports (BoP, current US$) in 2007 in Ukraine to that in United States?
Ensure brevity in your answer.  0.03. What is the ratio of the Imports (BoP, current US$) in 2008 in Ukraine to that in United States?
Keep it short and to the point. 0.04. What is the ratio of the Imports (BoP, current US$) in 2005 in Ukraine to that in Uruguay?
Keep it short and to the point. 8.94. What is the ratio of the Imports (BoP, current US$) of 2006 in Ukraine to that in Uruguay?
Make the answer very short. 8.75. What is the ratio of the Imports (BoP, current US$) of 2007 in Ukraine to that in Uruguay?
Ensure brevity in your answer.  10.26. What is the ratio of the Imports (BoP, current US$) of 2008 in Ukraine to that in Uruguay?
Keep it short and to the point. 9.37. What is the ratio of the Imports (BoP, current US$) in 2005 in United Kingdom to that in United States?
Offer a very short reply. 0.34. What is the ratio of the Imports (BoP, current US$) of 2006 in United Kingdom to that in United States?
Make the answer very short. 0.35. What is the ratio of the Imports (BoP, current US$) of 2007 in United Kingdom to that in United States?
Your response must be concise. 0.36. What is the ratio of the Imports (BoP, current US$) of 2008 in United Kingdom to that in United States?
Your answer should be very brief. 0.34. What is the ratio of the Imports (BoP, current US$) in 2005 in United Kingdom to that in Uruguay?
Keep it short and to the point. 145.7. What is the ratio of the Imports (BoP, current US$) in 2006 in United Kingdom to that in Uruguay?
Your answer should be compact. 132.64. What is the ratio of the Imports (BoP, current US$) in 2007 in United Kingdom to that in Uruguay?
Provide a succinct answer. 124.28. What is the ratio of the Imports (BoP, current US$) in 2008 in United Kingdom to that in Uruguay?
Your answer should be very brief. 83.77. What is the ratio of the Imports (BoP, current US$) in 2005 in United States to that in Uruguay?
Your answer should be compact. 426.25. What is the ratio of the Imports (BoP, current US$) in 2006 in United States to that in Uruguay?
Offer a very short reply. 377.63. What is the ratio of the Imports (BoP, current US$) of 2007 in United States to that in Uruguay?
Ensure brevity in your answer.  348.16. What is the ratio of the Imports (BoP, current US$) of 2008 in United States to that in Uruguay?
Give a very brief answer. 246.81. What is the difference between the highest and the second highest Imports (BoP, current US$) in 2005?
Offer a very short reply. 1.32e+12. What is the difference between the highest and the second highest Imports (BoP, current US$) in 2006?
Your response must be concise. 1.44e+12. What is the difference between the highest and the second highest Imports (BoP, current US$) in 2007?
Ensure brevity in your answer.  1.52e+12. What is the difference between the highest and the second highest Imports (BoP, current US$) of 2008?
Ensure brevity in your answer.  1.68e+12. What is the difference between the highest and the lowest Imports (BoP, current US$) of 2005?
Your answer should be compact. 2.00e+12. What is the difference between the highest and the lowest Imports (BoP, current US$) of 2006?
Provide a short and direct response. 2.21e+12. What is the difference between the highest and the lowest Imports (BoP, current US$) of 2007?
Make the answer very short. 2.35e+12. What is the difference between the highest and the lowest Imports (BoP, current US$) in 2008?
Your answer should be compact. 2.54e+12. 